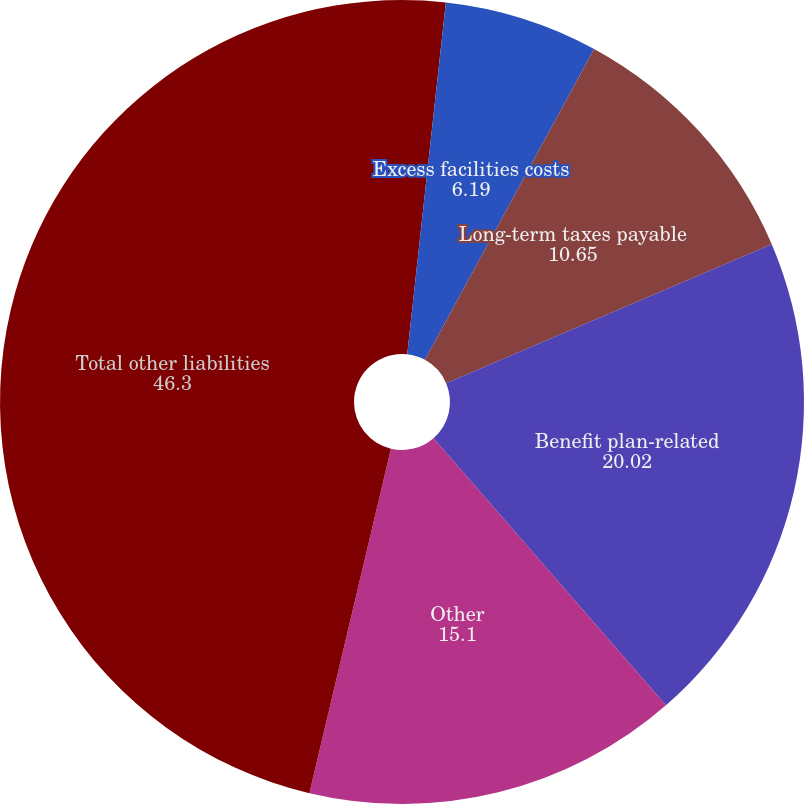Convert chart. <chart><loc_0><loc_0><loc_500><loc_500><pie_chart><fcel>Non-current deferred revenue<fcel>Excess facilities costs<fcel>Long-term taxes payable<fcel>Benefit plan-related<fcel>Other<fcel>Total other liabilities<nl><fcel>1.74%<fcel>6.19%<fcel>10.65%<fcel>20.02%<fcel>15.1%<fcel>46.3%<nl></chart> 